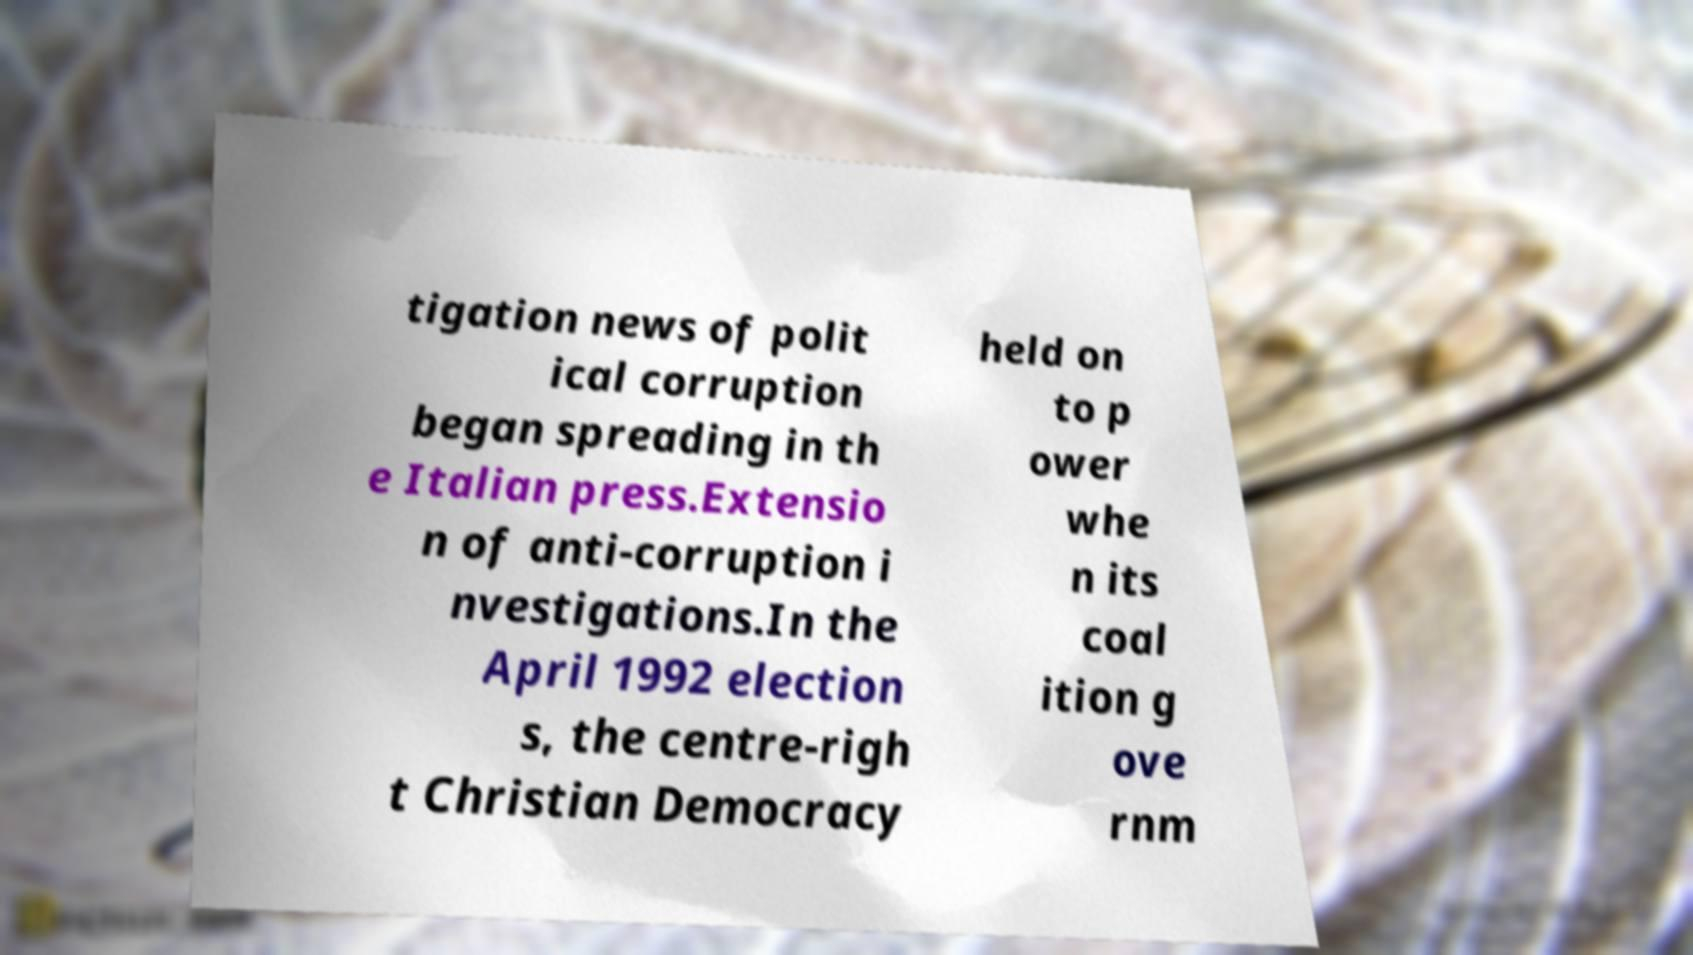Could you assist in decoding the text presented in this image and type it out clearly? tigation news of polit ical corruption began spreading in th e Italian press.Extensio n of anti-corruption i nvestigations.In the April 1992 election s, the centre-righ t Christian Democracy held on to p ower whe n its coal ition g ove rnm 